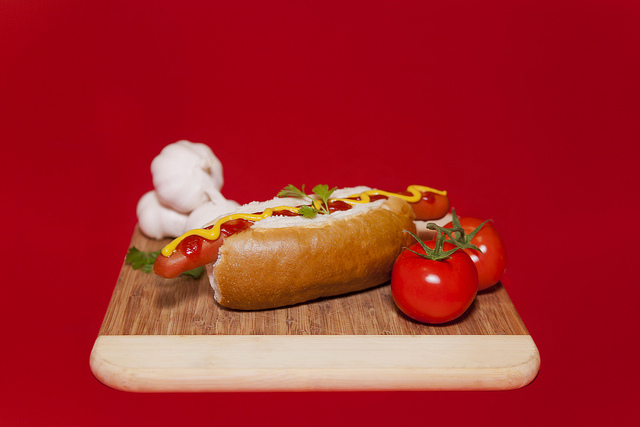Describe a fun day related to this meal. Imagine a sunny picnic day in the park with family and friends! Blankets spread out on the lush green grass, everyone gathering around a picnic basket filled with delights. Hot dogs like the one in the image are being passed around, garnished with fresh tomatoes and parsley, with everyone adding their favorite condiments. Kids are playing frisbee nearby, laughter filling the air. It’s a day of relaxation, good food, and bonding, where worries are left behind and memories are made. What would be a perfect beverage to accompany this hot dog? A tall, frosty glass of lemonade would pair beautifully with this hot dog. Its tangy, refreshing taste would complement the savory flavors of the hot dog, while providing a quick and satisfying quench to your thirst on a warm day. Alternatively, an ice-cold soda or a light beer would also be great choices to enhance your meal experience. 